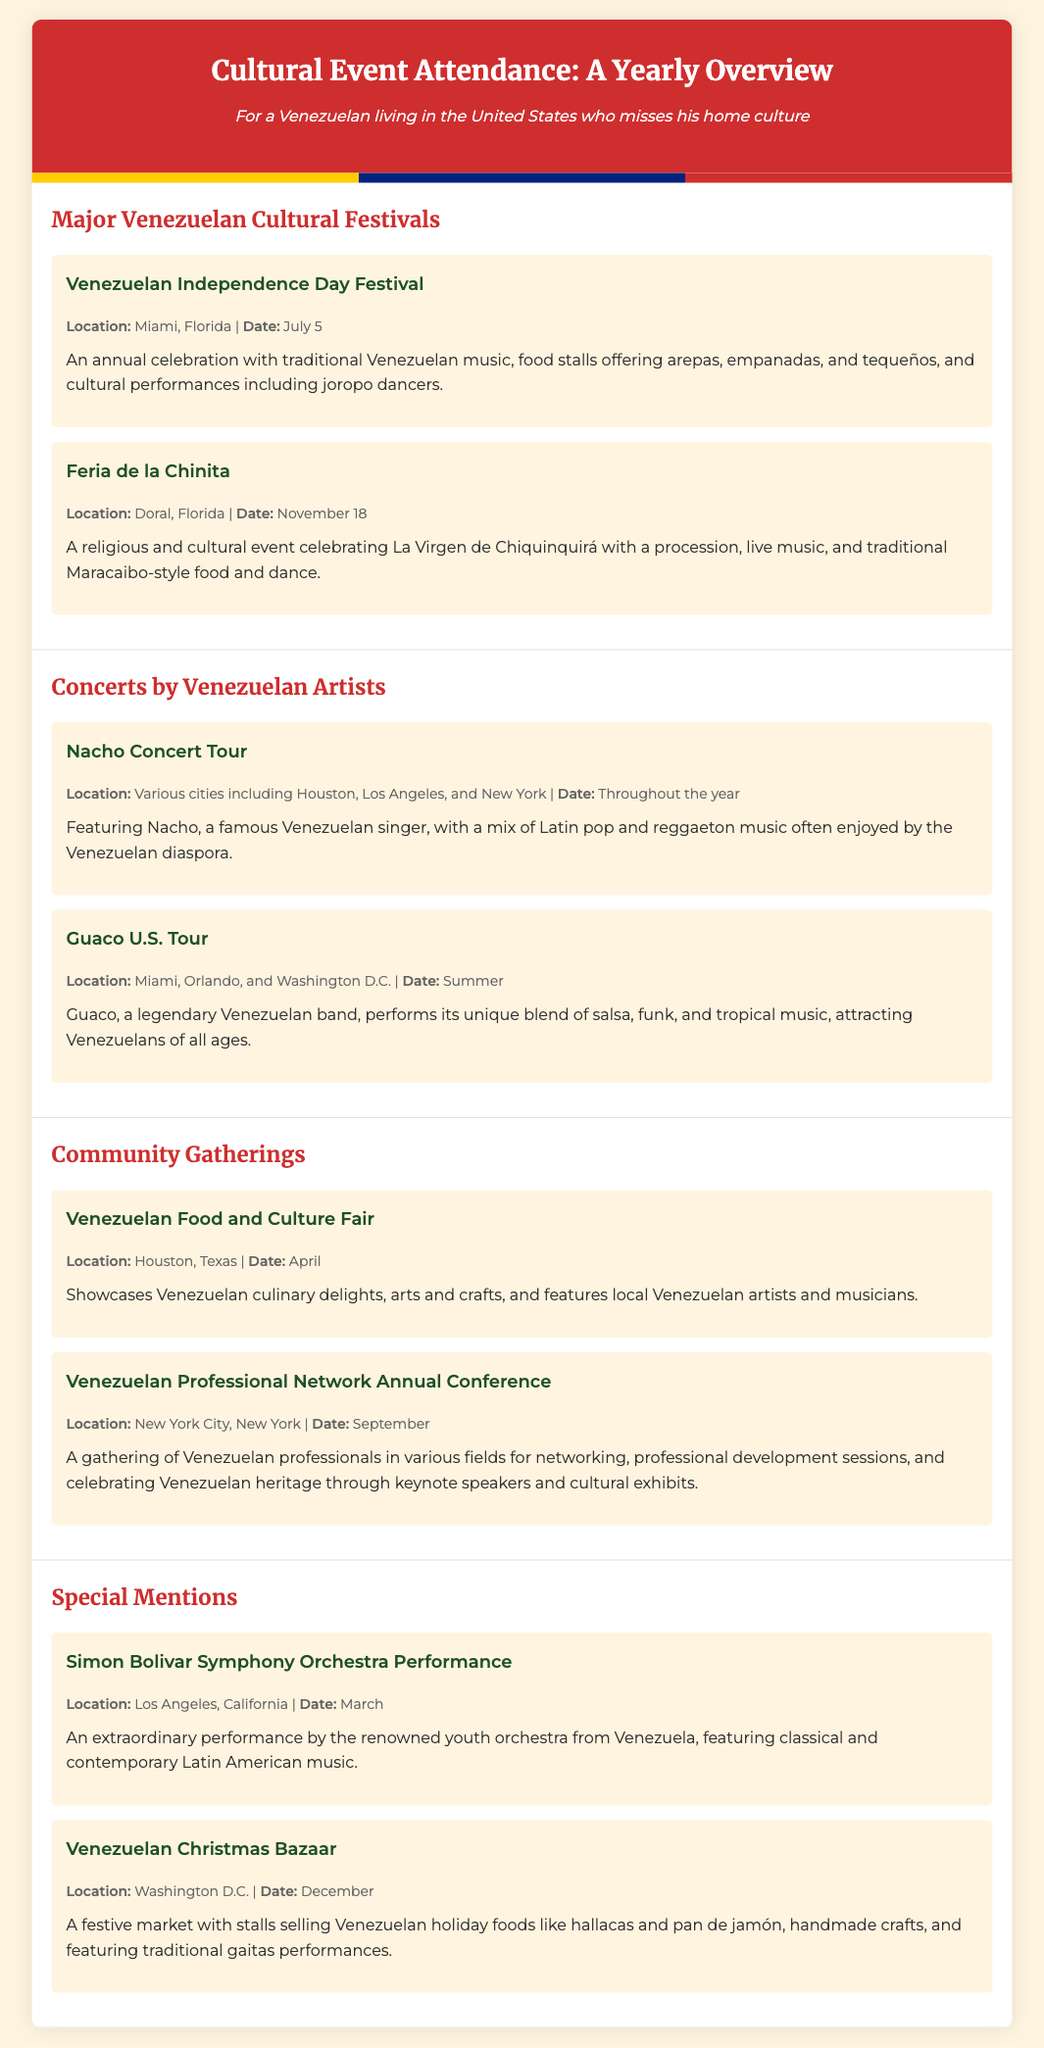What is the location of the Venezuelan Independence Day Festival? The document mentions that the Venezuelan Independence Day Festival is held in Miami, Florida.
Answer: Miami, Florida When is the Feria de la Chinita celebrated? According to the document, the Feria de la Chinita takes place on November 18.
Answer: November 18 What type of music does the Nacho Concert feature? The document states that the Nacho Concert features a mix of Latin pop and reggaeton music.
Answer: Latin pop and reggaeton Which event takes place in New York City? The document lists the Venezuelan Professional Network Annual Conference as taking place in New York City.
Answer: Venezuelan Professional Network Annual Conference What month is the Venezuelan Food and Culture Fair held? The document specifies that the Venezuelan Food and Culture Fair occurs in April.
Answer: April What is the main food featured at the Venezuelan Christmas Bazaar? The document states that the Venezuelan Christmas Bazaar has stalls selling holiday foods like hallacas.
Answer: Hallacas How many concerts by Venezuelan artists are listed in the document? The document mentions two concerts by Venezuelan artists: Nacho Concert Tour and Guaco U.S. Tour.
Answer: Two What is the purpose of the Venezuelan Professional Network Annual Conference? The document explains that it is a gathering for networking and professional development sessions for Venezuelans.
Answer: Networking and professional development Which event features traditional gaitas performances? The document indicates that the Venezuelan Christmas Bazaar features traditional gaitas performances.
Answer: Venezuelan Christmas Bazaar 